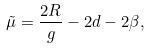<formula> <loc_0><loc_0><loc_500><loc_500>\tilde { \mu } = \frac { 2 R } { g } - 2 d - 2 \beta ,</formula> 